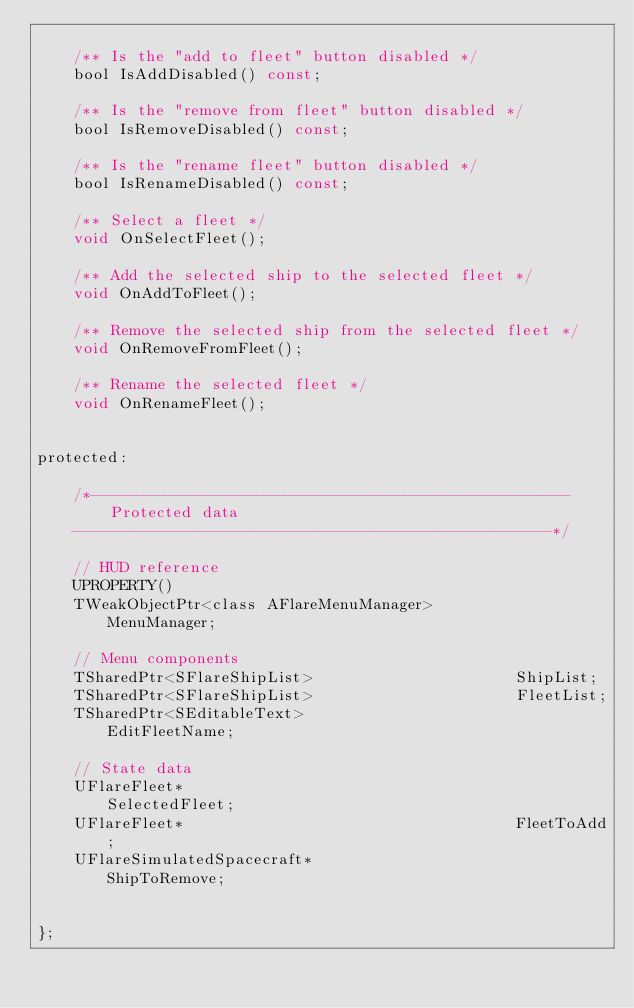Convert code to text. <code><loc_0><loc_0><loc_500><loc_500><_C_>
	/** Is the "add to fleet" button disabled */
	bool IsAddDisabled() const;

	/** Is the "remove from fleet" button disabled */
	bool IsRemoveDisabled() const;

	/** Is the "rename fleet" button disabled */
	bool IsRenameDisabled() const;

	/** Select a fleet */
	void OnSelectFleet();

	/** Add the selected ship to the selected fleet */
	void OnAddToFleet();

	/** Remove the selected ship from the selected fleet */
	void OnRemoveFromFleet();

	/** Rename the selected fleet */
	void OnRenameFleet();


protected:

	/*----------------------------------------------------
		Protected data
	----------------------------------------------------*/

	// HUD reference
	UPROPERTY()
	TWeakObjectPtr<class AFlareMenuManager>         MenuManager;

	// Menu components
	TSharedPtr<SFlareShipList>                      ShipList;
	TSharedPtr<SFlareShipList>                      FleetList;
	TSharedPtr<SEditableText>                       EditFleetName;

	// State data
	UFlareFleet*                                    SelectedFleet;
	UFlareFleet*                                    FleetToAdd;
	UFlareSimulatedSpacecraft*                      ShipToRemove;


};
</code> 